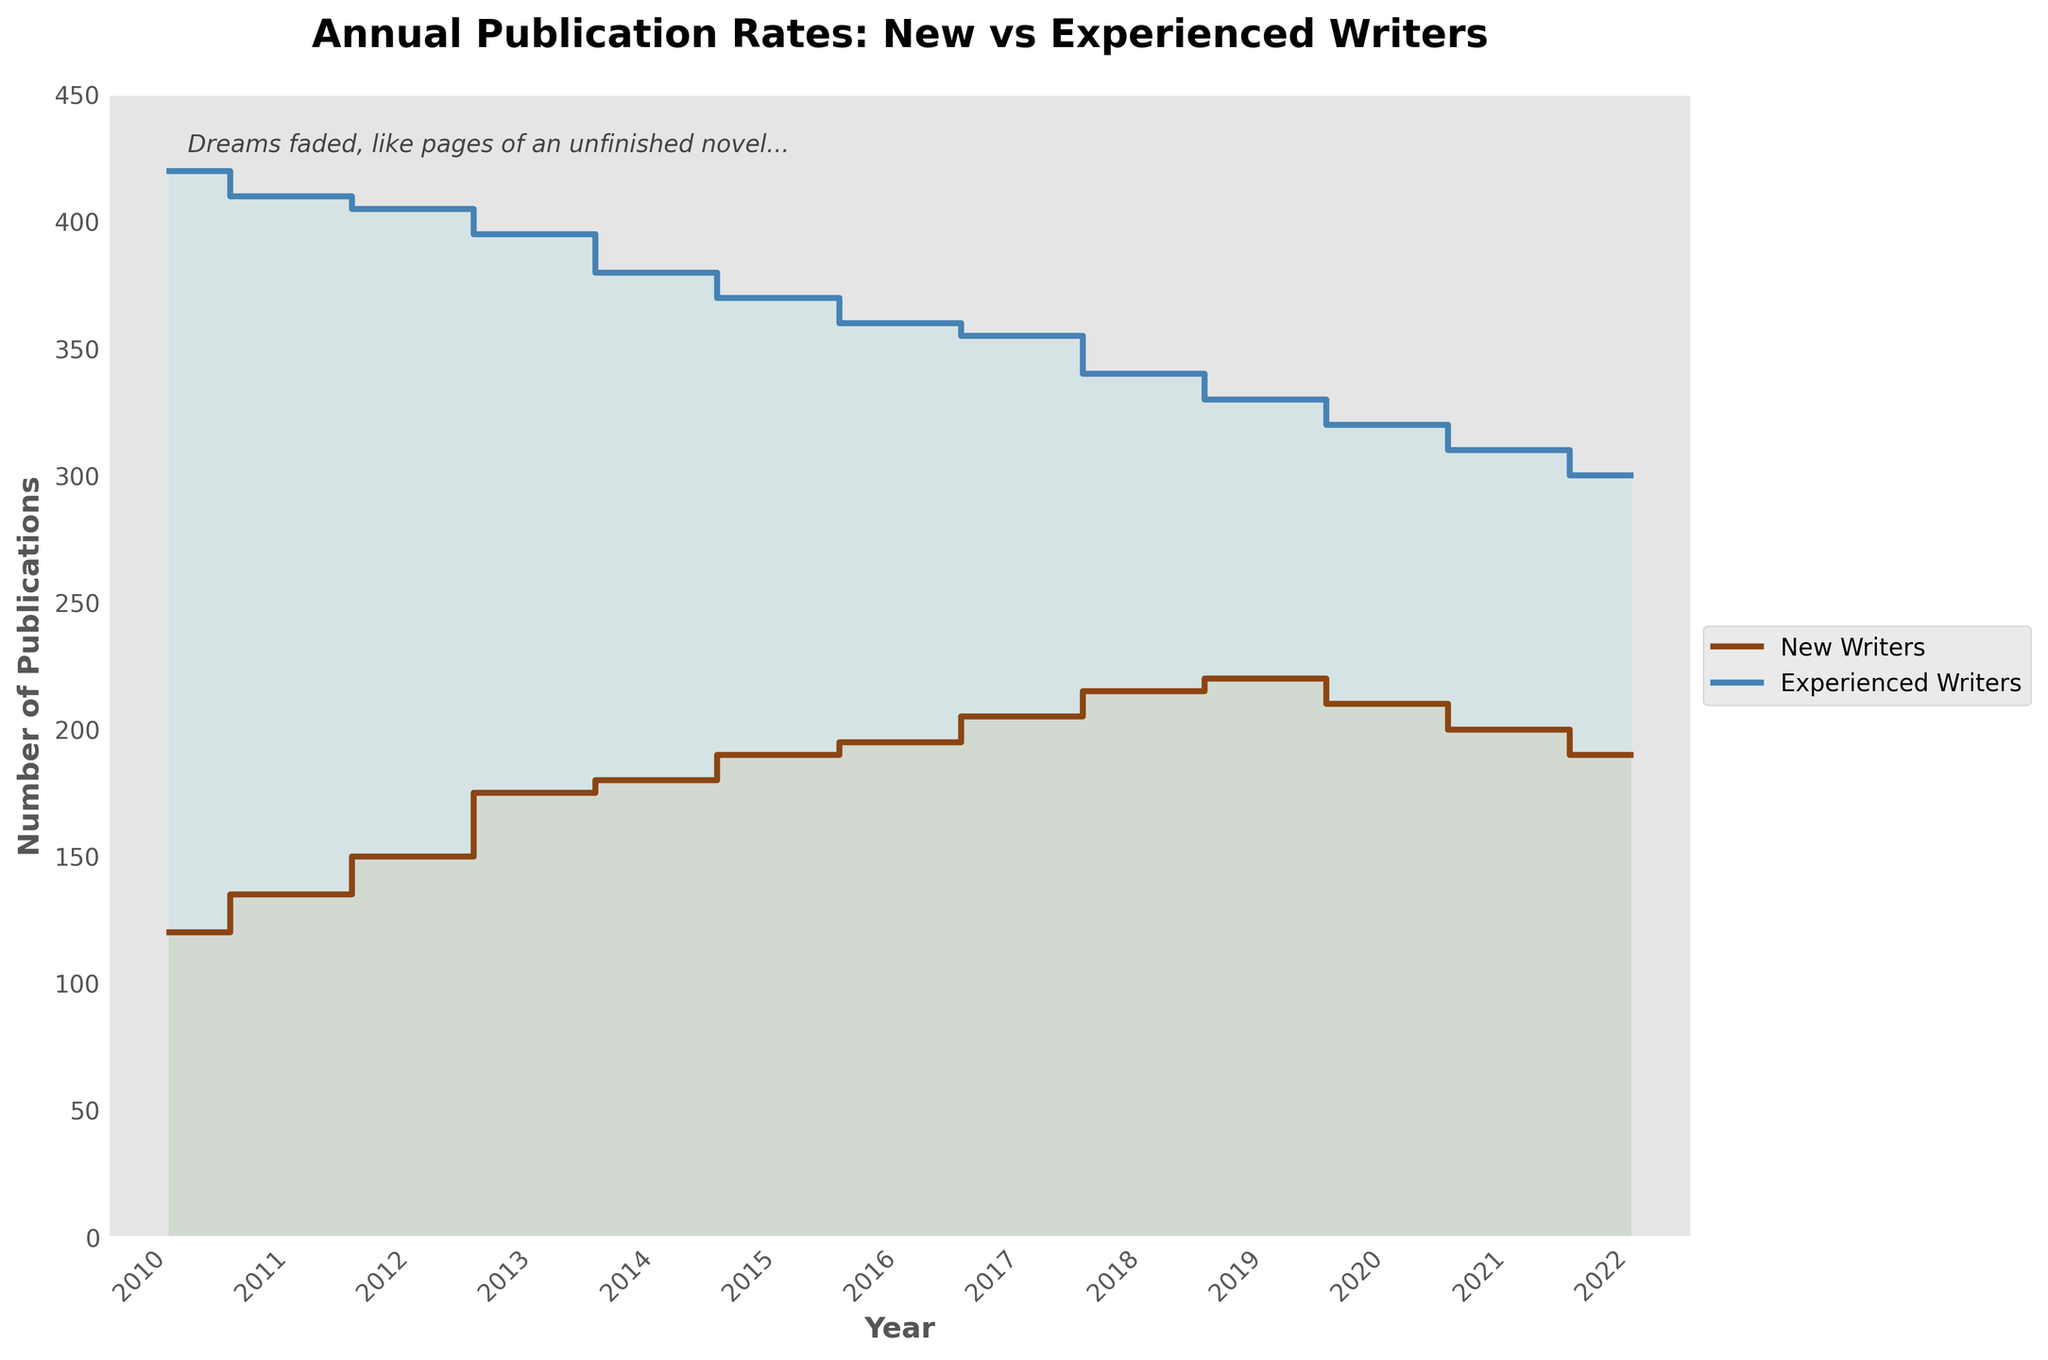What is the title of the figure? The title is located at the top of the figure and it reads: "Annual Publication Rates: New vs Experienced Writers".
Answer: Annual Publication Rates: New vs Experienced Writers What is the overall trend for new writers from 2010 to 2022? By examining the step plot, it's clear that the number of publications by new writers generally increased from 2010 peaking around 2019 and then declined until 2022.
Answer: Generally increasing until 2019, then decreasing Which year had the highest number of publications from new writers? The highest point on the plot for new writers can be seen in 2019, where the number reaches 220.
Answer: 2019 In which year do experienced writers have the least number of publications? The lowest point in the plot for experienced writers is seen in 2022, where the number is 300.
Answer: 2022 By how much did the number of publications by experienced writers decrease from 2010 to 2022? In 2010, the number of publications by experienced writers was 420 and in 2022, it was 300. The decrease can be calculated as 420 - 300.
Answer: 120 What was the difference in publications between new and experienced writers in 2020? In 2020, new writers had 210 publications, and experienced writers had 320 publications. The difference is 320 - 210.
Answer: 110 What is the overall trend for experienced writers from 2010 to 2022? By examining the step plot, it's observable that the number of publications by experienced writers steadily declined from 2010 through 2022.
Answer: Steadily declining In which year is the gap between new and experienced writers' publication rates the smallest? By visually inspecting the gaps between the lines, in 2014 the difference is smaller than in other years, with new writers at 180 and experienced writers at 380.
Answer: 2014 